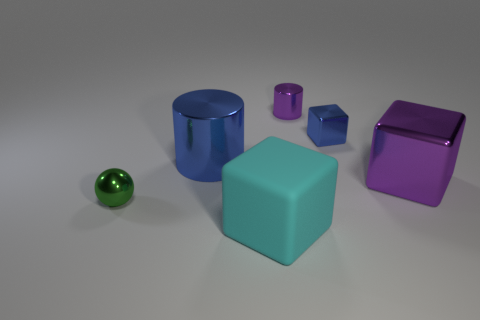Add 2 yellow metal blocks. How many objects exist? 8 Subtract all balls. How many objects are left? 5 Subtract 0 yellow spheres. How many objects are left? 6 Subtract all tiny brown cylinders. Subtract all big blue objects. How many objects are left? 5 Add 1 small green metal objects. How many small green metal objects are left? 2 Add 6 large cyan objects. How many large cyan objects exist? 7 